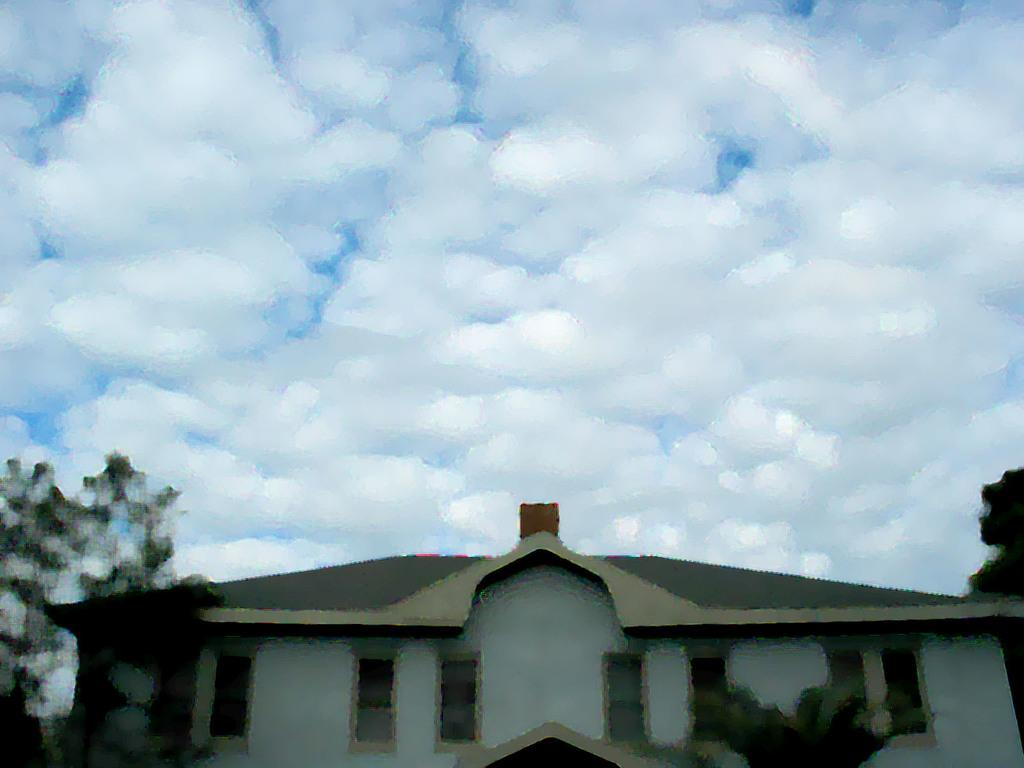What type of structure is in the image? There is a house in the image. What features can be seen on the house? The house has windows. What other objects or elements are in the image? There are trees and the sky is visible at the top of the image. Can you describe the sky in the image? Clouds are present in the sky. What type of pen is being used to write on the roof of the house in the image? There is no pen or writing on the roof of the house in the image. What invention is being demonstrated by the trees in the image? There is no invention being demonstrated by the trees in the image; they are simply trees. 